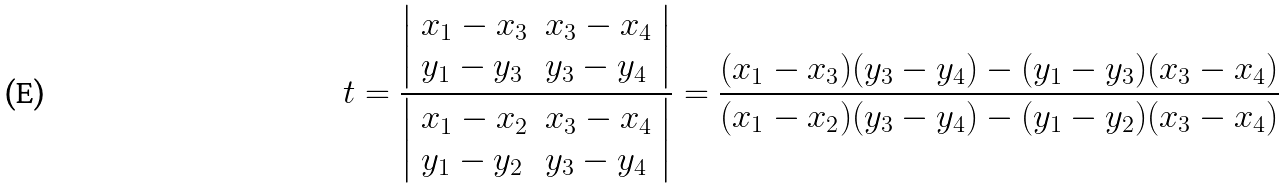Convert formula to latex. <formula><loc_0><loc_0><loc_500><loc_500>t = { \frac { \left | \begin{array} { l l } { x _ { 1 } - x _ { 3 } } & { x _ { 3 } - x _ { 4 } } \\ { y _ { 1 } - y _ { 3 } } & { y _ { 3 } - y _ { 4 } } \end{array} \right | } { \left | \begin{array} { l l } { x _ { 1 } - x _ { 2 } } & { x _ { 3 } - x _ { 4 } } \\ { y _ { 1 } - y _ { 2 } } & { y _ { 3 } - y _ { 4 } } \end{array} \right | } } = { \frac { ( x _ { 1 } - x _ { 3 } ) ( y _ { 3 } - y _ { 4 } ) - ( y _ { 1 } - y _ { 3 } ) ( x _ { 3 } - x _ { 4 } ) } { ( x _ { 1 } - x _ { 2 } ) ( y _ { 3 } - y _ { 4 } ) - ( y _ { 1 } - y _ { 2 } ) ( x _ { 3 } - x _ { 4 } ) } }</formula> 